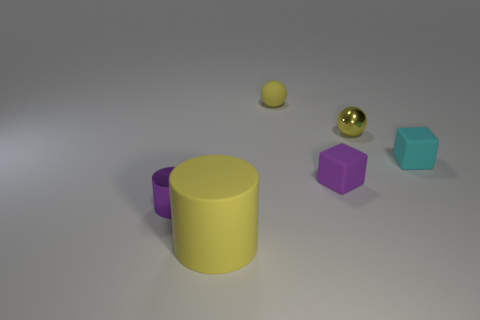There is a purple object to the left of the yellow object in front of the small purple metal object; what is its shape?
Your response must be concise. Cylinder. Are there fewer tiny yellow matte things right of the big object than matte cubes left of the purple metal thing?
Ensure brevity in your answer.  No. There is another purple object that is the same shape as the large matte thing; what is its size?
Make the answer very short. Small. Is there anything else that has the same size as the cyan object?
Your response must be concise. Yes. What number of things are either yellow things behind the small purple cylinder or small rubber blocks in front of the cyan rubber object?
Provide a short and direct response. 3. Is the size of the matte sphere the same as the yellow rubber cylinder?
Your response must be concise. No. Are there more tiny yellow metallic spheres than cubes?
Ensure brevity in your answer.  No. What number of other objects are there of the same color as the rubber cylinder?
Give a very brief answer. 2. How many things are either small metallic things or purple metal things?
Offer a very short reply. 2. There is a tiny thing that is on the left side of the tiny yellow matte ball; is its shape the same as the large yellow matte object?
Keep it short and to the point. Yes. 